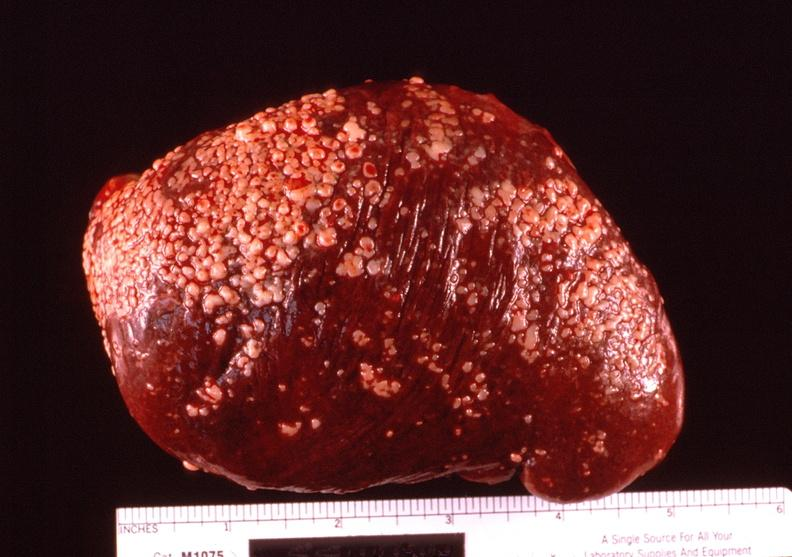what does this image show?
Answer the question using a single word or phrase. Spleen 